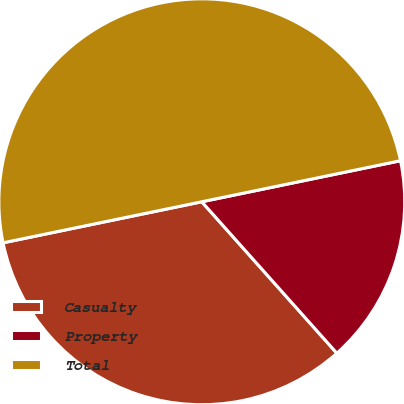Convert chart to OTSL. <chart><loc_0><loc_0><loc_500><loc_500><pie_chart><fcel>Casualty<fcel>Property<fcel>Total<nl><fcel>33.35%<fcel>16.65%<fcel>50.0%<nl></chart> 